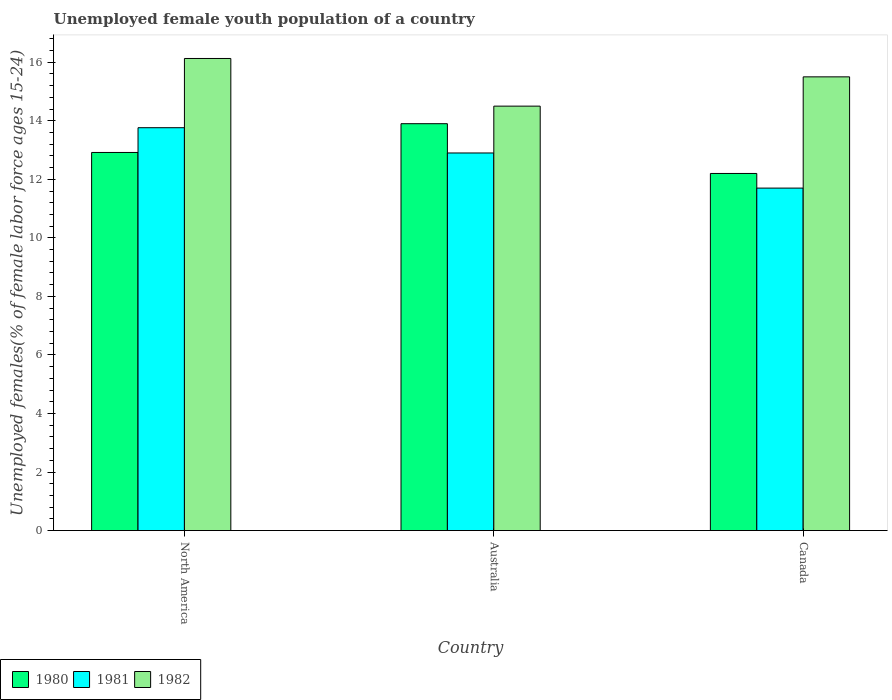How many different coloured bars are there?
Offer a very short reply. 3. Are the number of bars per tick equal to the number of legend labels?
Offer a terse response. Yes. Are the number of bars on each tick of the X-axis equal?
Provide a short and direct response. Yes. How many bars are there on the 3rd tick from the right?
Your answer should be compact. 3. In how many cases, is the number of bars for a given country not equal to the number of legend labels?
Provide a short and direct response. 0. What is the percentage of unemployed female youth population in 1982 in Canada?
Keep it short and to the point. 15.5. Across all countries, what is the maximum percentage of unemployed female youth population in 1982?
Offer a very short reply. 16.13. Across all countries, what is the minimum percentage of unemployed female youth population in 1980?
Provide a short and direct response. 12.2. In which country was the percentage of unemployed female youth population in 1981 maximum?
Ensure brevity in your answer.  North America. In which country was the percentage of unemployed female youth population in 1982 minimum?
Make the answer very short. Australia. What is the total percentage of unemployed female youth population in 1982 in the graph?
Give a very brief answer. 46.13. What is the difference between the percentage of unemployed female youth population in 1982 in Australia and that in North America?
Offer a very short reply. -1.63. What is the difference between the percentage of unemployed female youth population in 1982 in North America and the percentage of unemployed female youth population in 1981 in Canada?
Give a very brief answer. 4.43. What is the average percentage of unemployed female youth population in 1980 per country?
Offer a very short reply. 13.01. What is the difference between the percentage of unemployed female youth population of/in 1980 and percentage of unemployed female youth population of/in 1982 in Australia?
Make the answer very short. -0.6. What is the ratio of the percentage of unemployed female youth population in 1980 in Australia to that in Canada?
Your answer should be very brief. 1.14. Is the percentage of unemployed female youth population in 1982 in Canada less than that in North America?
Ensure brevity in your answer.  Yes. What is the difference between the highest and the second highest percentage of unemployed female youth population in 1982?
Make the answer very short. 1.63. What is the difference between the highest and the lowest percentage of unemployed female youth population in 1981?
Your response must be concise. 2.06. In how many countries, is the percentage of unemployed female youth population in 1981 greater than the average percentage of unemployed female youth population in 1981 taken over all countries?
Your answer should be compact. 2. Is the sum of the percentage of unemployed female youth population in 1980 in Canada and North America greater than the maximum percentage of unemployed female youth population in 1981 across all countries?
Keep it short and to the point. Yes. Is it the case that in every country, the sum of the percentage of unemployed female youth population in 1980 and percentage of unemployed female youth population in 1982 is greater than the percentage of unemployed female youth population in 1981?
Offer a very short reply. Yes. How many bars are there?
Your answer should be compact. 9. Are all the bars in the graph horizontal?
Make the answer very short. No. How many countries are there in the graph?
Keep it short and to the point. 3. What is the difference between two consecutive major ticks on the Y-axis?
Provide a succinct answer. 2. Are the values on the major ticks of Y-axis written in scientific E-notation?
Your response must be concise. No. Does the graph contain any zero values?
Keep it short and to the point. No. Does the graph contain grids?
Your answer should be very brief. No. Where does the legend appear in the graph?
Offer a very short reply. Bottom left. What is the title of the graph?
Give a very brief answer. Unemployed female youth population of a country. What is the label or title of the Y-axis?
Provide a short and direct response. Unemployed females(% of female labor force ages 15-24). What is the Unemployed females(% of female labor force ages 15-24) of 1980 in North America?
Give a very brief answer. 12.92. What is the Unemployed females(% of female labor force ages 15-24) of 1981 in North America?
Keep it short and to the point. 13.76. What is the Unemployed females(% of female labor force ages 15-24) of 1982 in North America?
Provide a short and direct response. 16.13. What is the Unemployed females(% of female labor force ages 15-24) in 1980 in Australia?
Ensure brevity in your answer.  13.9. What is the Unemployed females(% of female labor force ages 15-24) in 1981 in Australia?
Provide a short and direct response. 12.9. What is the Unemployed females(% of female labor force ages 15-24) of 1982 in Australia?
Your answer should be compact. 14.5. What is the Unemployed females(% of female labor force ages 15-24) of 1980 in Canada?
Offer a terse response. 12.2. What is the Unemployed females(% of female labor force ages 15-24) of 1981 in Canada?
Ensure brevity in your answer.  11.7. What is the Unemployed females(% of female labor force ages 15-24) in 1982 in Canada?
Provide a short and direct response. 15.5. Across all countries, what is the maximum Unemployed females(% of female labor force ages 15-24) of 1980?
Give a very brief answer. 13.9. Across all countries, what is the maximum Unemployed females(% of female labor force ages 15-24) in 1981?
Ensure brevity in your answer.  13.76. Across all countries, what is the maximum Unemployed females(% of female labor force ages 15-24) in 1982?
Your response must be concise. 16.13. Across all countries, what is the minimum Unemployed females(% of female labor force ages 15-24) of 1980?
Your response must be concise. 12.2. Across all countries, what is the minimum Unemployed females(% of female labor force ages 15-24) of 1981?
Offer a very short reply. 11.7. What is the total Unemployed females(% of female labor force ages 15-24) of 1980 in the graph?
Make the answer very short. 39.02. What is the total Unemployed females(% of female labor force ages 15-24) in 1981 in the graph?
Your answer should be very brief. 38.36. What is the total Unemployed females(% of female labor force ages 15-24) in 1982 in the graph?
Ensure brevity in your answer.  46.13. What is the difference between the Unemployed females(% of female labor force ages 15-24) of 1980 in North America and that in Australia?
Make the answer very short. -0.98. What is the difference between the Unemployed females(% of female labor force ages 15-24) in 1981 in North America and that in Australia?
Give a very brief answer. 0.86. What is the difference between the Unemployed females(% of female labor force ages 15-24) in 1982 in North America and that in Australia?
Make the answer very short. 1.63. What is the difference between the Unemployed females(% of female labor force ages 15-24) of 1980 in North America and that in Canada?
Offer a very short reply. 0.72. What is the difference between the Unemployed females(% of female labor force ages 15-24) in 1981 in North America and that in Canada?
Keep it short and to the point. 2.06. What is the difference between the Unemployed females(% of female labor force ages 15-24) in 1982 in North America and that in Canada?
Provide a short and direct response. 0.63. What is the difference between the Unemployed females(% of female labor force ages 15-24) of 1980 in Australia and that in Canada?
Your response must be concise. 1.7. What is the difference between the Unemployed females(% of female labor force ages 15-24) of 1981 in Australia and that in Canada?
Offer a terse response. 1.2. What is the difference between the Unemployed females(% of female labor force ages 15-24) in 1980 in North America and the Unemployed females(% of female labor force ages 15-24) in 1981 in Australia?
Your answer should be compact. 0.02. What is the difference between the Unemployed females(% of female labor force ages 15-24) of 1980 in North America and the Unemployed females(% of female labor force ages 15-24) of 1982 in Australia?
Provide a short and direct response. -1.58. What is the difference between the Unemployed females(% of female labor force ages 15-24) of 1981 in North America and the Unemployed females(% of female labor force ages 15-24) of 1982 in Australia?
Give a very brief answer. -0.74. What is the difference between the Unemployed females(% of female labor force ages 15-24) of 1980 in North America and the Unemployed females(% of female labor force ages 15-24) of 1981 in Canada?
Provide a succinct answer. 1.22. What is the difference between the Unemployed females(% of female labor force ages 15-24) of 1980 in North America and the Unemployed females(% of female labor force ages 15-24) of 1982 in Canada?
Provide a succinct answer. -2.58. What is the difference between the Unemployed females(% of female labor force ages 15-24) of 1981 in North America and the Unemployed females(% of female labor force ages 15-24) of 1982 in Canada?
Your answer should be very brief. -1.74. What is the difference between the Unemployed females(% of female labor force ages 15-24) in 1980 in Australia and the Unemployed females(% of female labor force ages 15-24) in 1981 in Canada?
Keep it short and to the point. 2.2. What is the difference between the Unemployed females(% of female labor force ages 15-24) of 1981 in Australia and the Unemployed females(% of female labor force ages 15-24) of 1982 in Canada?
Keep it short and to the point. -2.6. What is the average Unemployed females(% of female labor force ages 15-24) of 1980 per country?
Your response must be concise. 13.01. What is the average Unemployed females(% of female labor force ages 15-24) in 1981 per country?
Your answer should be compact. 12.79. What is the average Unemployed females(% of female labor force ages 15-24) of 1982 per country?
Your response must be concise. 15.38. What is the difference between the Unemployed females(% of female labor force ages 15-24) in 1980 and Unemployed females(% of female labor force ages 15-24) in 1981 in North America?
Make the answer very short. -0.85. What is the difference between the Unemployed females(% of female labor force ages 15-24) in 1980 and Unemployed females(% of female labor force ages 15-24) in 1982 in North America?
Ensure brevity in your answer.  -3.21. What is the difference between the Unemployed females(% of female labor force ages 15-24) of 1981 and Unemployed females(% of female labor force ages 15-24) of 1982 in North America?
Make the answer very short. -2.37. What is the difference between the Unemployed females(% of female labor force ages 15-24) of 1980 and Unemployed females(% of female labor force ages 15-24) of 1982 in Australia?
Offer a very short reply. -0.6. What is the difference between the Unemployed females(% of female labor force ages 15-24) of 1980 and Unemployed females(% of female labor force ages 15-24) of 1981 in Canada?
Give a very brief answer. 0.5. What is the ratio of the Unemployed females(% of female labor force ages 15-24) in 1980 in North America to that in Australia?
Your answer should be very brief. 0.93. What is the ratio of the Unemployed females(% of female labor force ages 15-24) of 1981 in North America to that in Australia?
Keep it short and to the point. 1.07. What is the ratio of the Unemployed females(% of female labor force ages 15-24) in 1982 in North America to that in Australia?
Offer a very short reply. 1.11. What is the ratio of the Unemployed females(% of female labor force ages 15-24) of 1980 in North America to that in Canada?
Provide a short and direct response. 1.06. What is the ratio of the Unemployed females(% of female labor force ages 15-24) of 1981 in North America to that in Canada?
Your answer should be compact. 1.18. What is the ratio of the Unemployed females(% of female labor force ages 15-24) of 1982 in North America to that in Canada?
Your answer should be very brief. 1.04. What is the ratio of the Unemployed females(% of female labor force ages 15-24) in 1980 in Australia to that in Canada?
Your answer should be compact. 1.14. What is the ratio of the Unemployed females(% of female labor force ages 15-24) of 1981 in Australia to that in Canada?
Ensure brevity in your answer.  1.1. What is the ratio of the Unemployed females(% of female labor force ages 15-24) in 1982 in Australia to that in Canada?
Provide a succinct answer. 0.94. What is the difference between the highest and the second highest Unemployed females(% of female labor force ages 15-24) in 1980?
Provide a short and direct response. 0.98. What is the difference between the highest and the second highest Unemployed females(% of female labor force ages 15-24) of 1981?
Ensure brevity in your answer.  0.86. What is the difference between the highest and the second highest Unemployed females(% of female labor force ages 15-24) of 1982?
Your response must be concise. 0.63. What is the difference between the highest and the lowest Unemployed females(% of female labor force ages 15-24) of 1981?
Give a very brief answer. 2.06. What is the difference between the highest and the lowest Unemployed females(% of female labor force ages 15-24) of 1982?
Give a very brief answer. 1.63. 